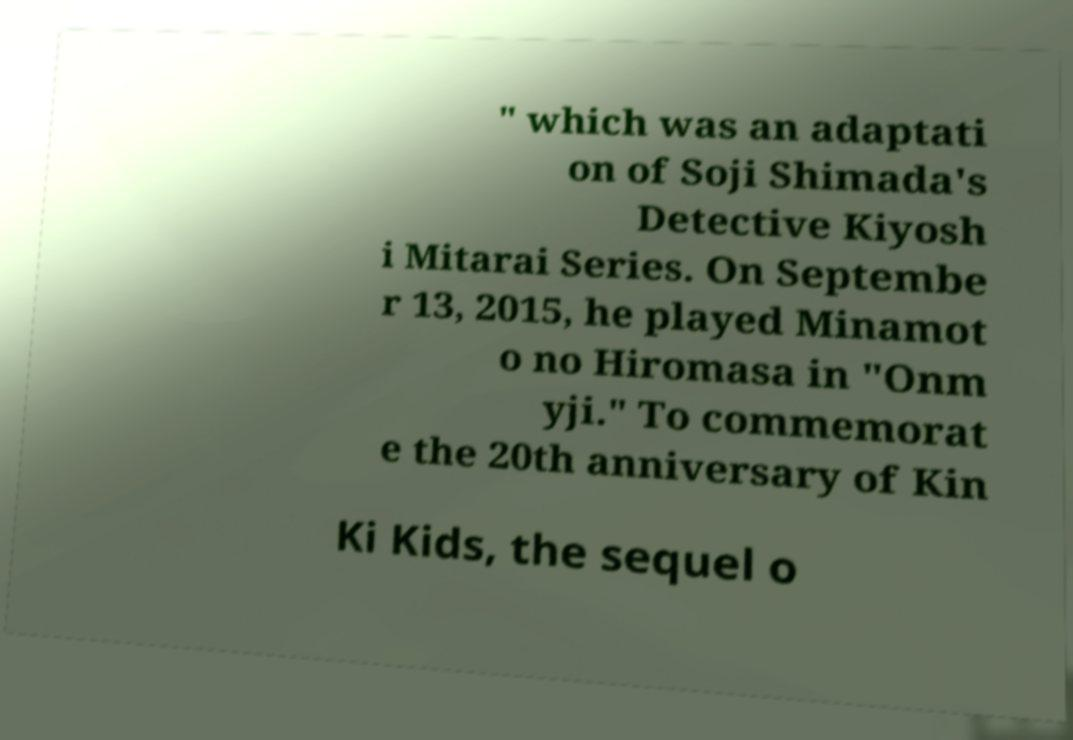There's text embedded in this image that I need extracted. Can you transcribe it verbatim? " which was an adaptati on of Soji Shimada's Detective Kiyosh i Mitarai Series. On Septembe r 13, 2015, he played Minamot o no Hiromasa in "Onm yji." To commemorat e the 20th anniversary of Kin Ki Kids, the sequel o 